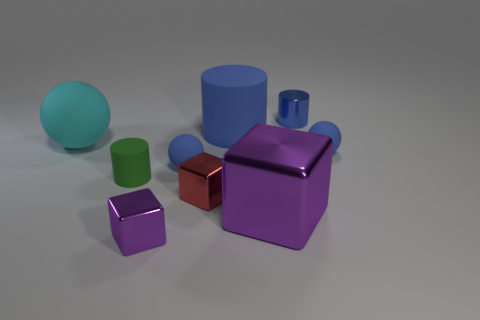Are the small green object and the large blue cylinder made of the same material?
Provide a succinct answer. Yes. What number of other objects are the same shape as the red metallic thing?
Ensure brevity in your answer.  2. What is the color of the tiny object on the right side of the small metallic object that is on the right side of the large metal block on the right side of the small green object?
Keep it short and to the point. Blue. Do the large rubber object that is on the right side of the big cyan ball and the large cyan object have the same shape?
Offer a very short reply. No. How many blue metallic cylinders are there?
Your answer should be compact. 1. What number of green rubber things have the same size as the green matte cylinder?
Offer a terse response. 0. What is the cyan sphere made of?
Offer a very short reply. Rubber. Does the big metal object have the same color as the small metallic object on the left side of the tiny red metallic object?
Keep it short and to the point. Yes. There is a metal thing that is behind the big purple block and on the left side of the big block; what size is it?
Provide a short and direct response. Small. What shape is the blue object that is made of the same material as the tiny red cube?
Your answer should be compact. Cylinder. 